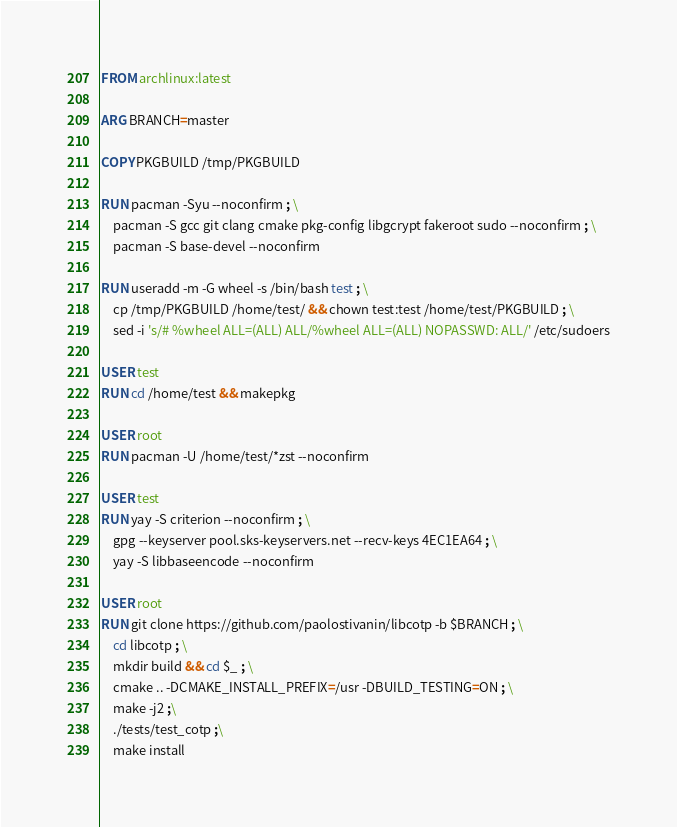Convert code to text. <code><loc_0><loc_0><loc_500><loc_500><_Dockerfile_>FROM archlinux:latest

ARG BRANCH=master

COPY PKGBUILD /tmp/PKGBUILD

RUN pacman -Syu --noconfirm ; \
    pacman -S gcc git clang cmake pkg-config libgcrypt fakeroot sudo --noconfirm ; \
    pacman -S base-devel --noconfirm

RUN useradd -m -G wheel -s /bin/bash test ; \
    cp /tmp/PKGBUILD /home/test/ && chown test:test /home/test/PKGBUILD ; \
    sed -i 's/# %wheel ALL=(ALL) ALL/%wheel ALL=(ALL) NOPASSWD: ALL/' /etc/sudoers

USER test
RUN cd /home/test && makepkg

USER root
RUN pacman -U /home/test/*zst --noconfirm

USER test
RUN yay -S criterion --noconfirm ; \
    gpg --keyserver pool.sks-keyservers.net --recv-keys 4EC1EA64 ; \
    yay -S libbaseencode --noconfirm

USER root
RUN git clone https://github.com/paolostivanin/libcotp -b $BRANCH ; \
    cd libcotp ; \
    mkdir build && cd $_ ; \
    cmake .. -DCMAKE_INSTALL_PREFIX=/usr -DBUILD_TESTING=ON ; \
    make -j2 ;\
    ./tests/test_cotp ;\
    make install

</code> 